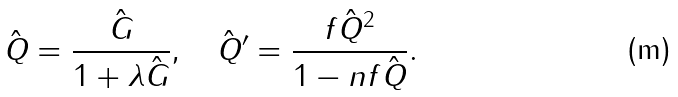Convert formula to latex. <formula><loc_0><loc_0><loc_500><loc_500>\hat { Q } = \frac { \hat { G } } { 1 + \lambda \hat { G } } , \quad \hat { Q } ^ { \prime } = \frac { f \hat { Q } ^ { 2 } } { 1 - n f \hat { Q } } .</formula> 